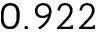<formula> <loc_0><loc_0><loc_500><loc_500>0 . 9 2 2</formula> 